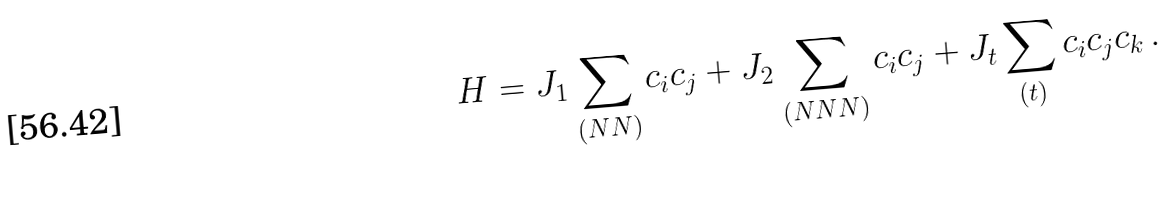<formula> <loc_0><loc_0><loc_500><loc_500>H = J _ { 1 } \sum _ { ( N N ) } c _ { i } c _ { j } + J _ { 2 } \sum _ { ( N N N ) } c _ { i } c _ { j } + J _ { t } \sum _ { ( t ) } c _ { i } c _ { j } c _ { k } \, .</formula> 